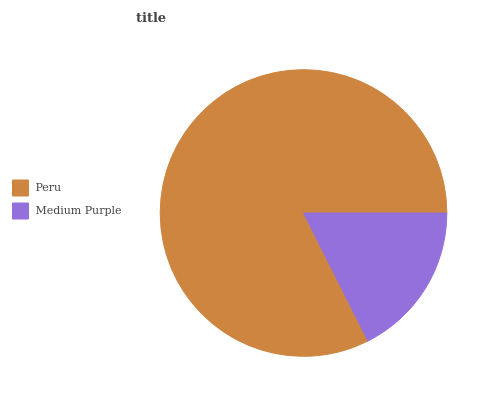Is Medium Purple the minimum?
Answer yes or no. Yes. Is Peru the maximum?
Answer yes or no. Yes. Is Medium Purple the maximum?
Answer yes or no. No. Is Peru greater than Medium Purple?
Answer yes or no. Yes. Is Medium Purple less than Peru?
Answer yes or no. Yes. Is Medium Purple greater than Peru?
Answer yes or no. No. Is Peru less than Medium Purple?
Answer yes or no. No. Is Peru the high median?
Answer yes or no. Yes. Is Medium Purple the low median?
Answer yes or no. Yes. Is Medium Purple the high median?
Answer yes or no. No. Is Peru the low median?
Answer yes or no. No. 